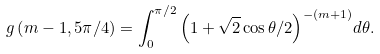<formula> <loc_0><loc_0><loc_500><loc_500>g \left ( m - 1 , { 5 \pi } / { 4 } \right ) = \int _ { 0 } ^ { \pi / 2 } { \left ( 1 + { \sqrt { 2 } } \cos \theta / { 2 } \right ) ^ { - ( m + 1 ) } } d \theta .</formula> 